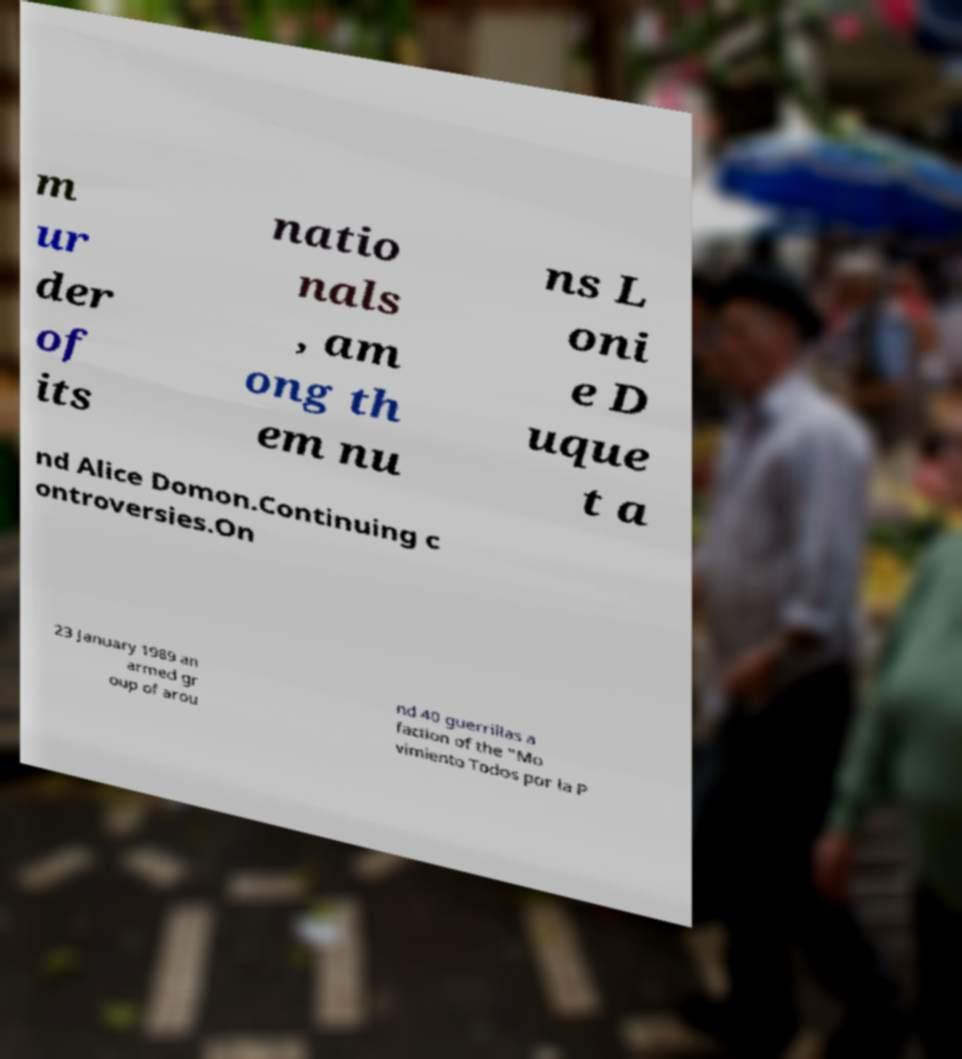Please identify and transcribe the text found in this image. m ur der of its natio nals , am ong th em nu ns L oni e D uque t a nd Alice Domon.Continuing c ontroversies.On 23 January 1989 an armed gr oup of arou nd 40 guerrillas a faction of the "Mo vimiento Todos por la P 